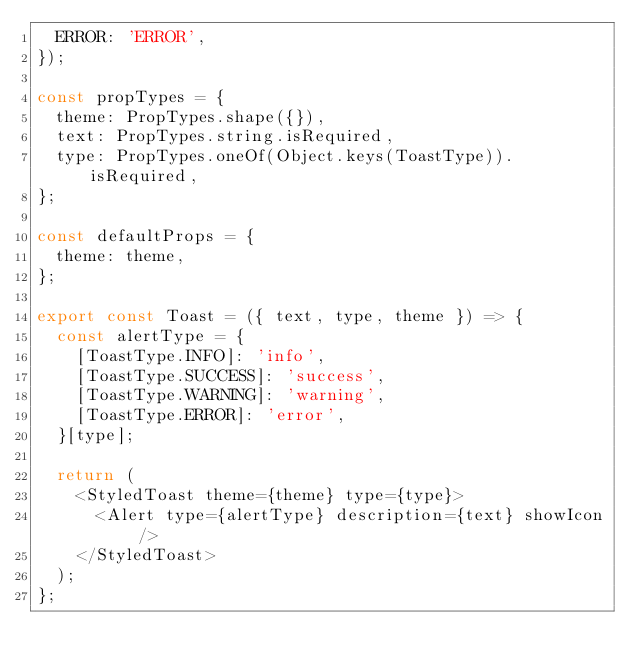Convert code to text. <code><loc_0><loc_0><loc_500><loc_500><_JavaScript_>  ERROR: 'ERROR',
});

const propTypes = {
  theme: PropTypes.shape({}),
  text: PropTypes.string.isRequired,
  type: PropTypes.oneOf(Object.keys(ToastType)).isRequired,
};

const defaultProps = {
  theme: theme,
};

export const Toast = ({ text, type, theme }) => {
  const alertType = {
    [ToastType.INFO]: 'info',
    [ToastType.SUCCESS]: 'success',
    [ToastType.WARNING]: 'warning',
    [ToastType.ERROR]: 'error',
  }[type];

  return (
    <StyledToast theme={theme} type={type}>
      <Alert type={alertType} description={text} showIcon />
    </StyledToast>
  );
};
</code> 